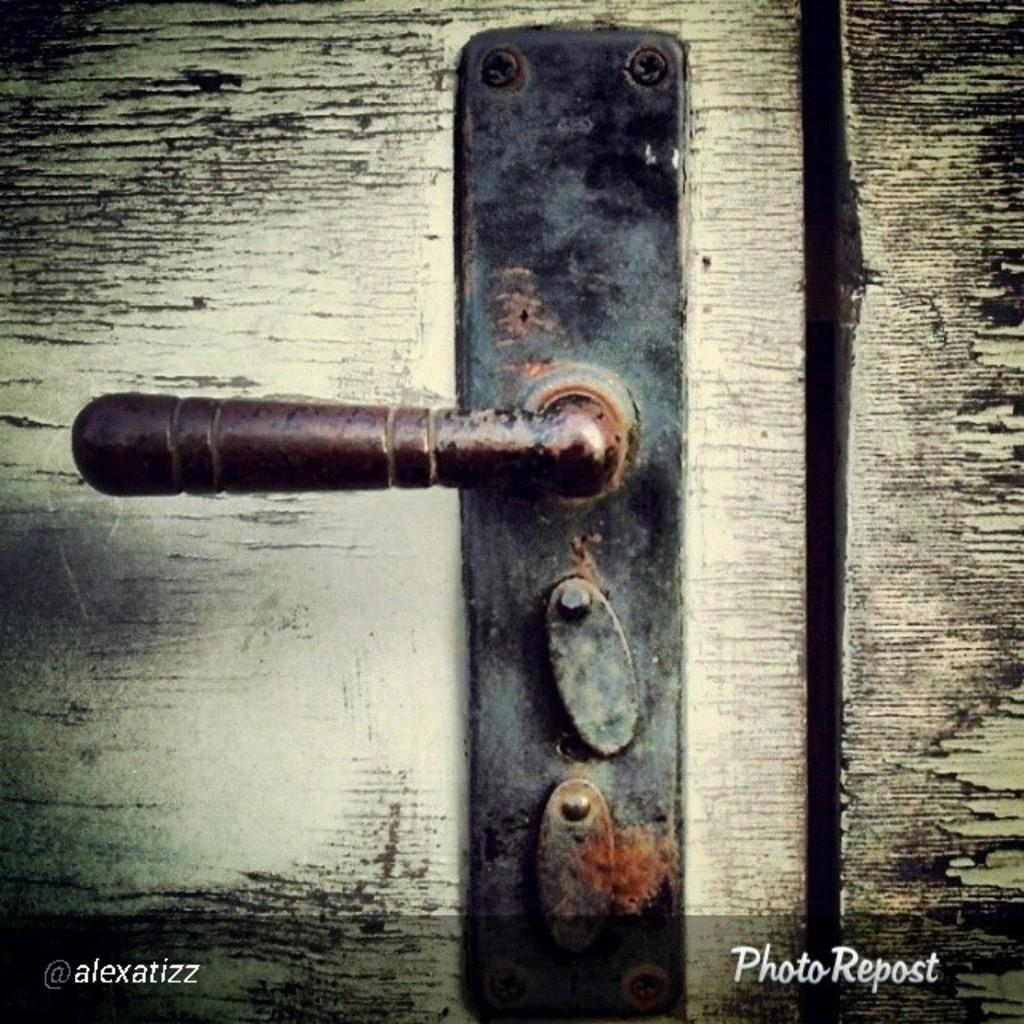What is the main object in the image? There is a door lock in the image. Is there any text associated with the image? Yes, there is some text at the bottom of the image. How many noses can be seen on the door lock in the image? There are no noses present on the door lock in the image. What type of hands are holding the door lock in the image? There are no hands visible in the image, as it only features a door lock and some text. 